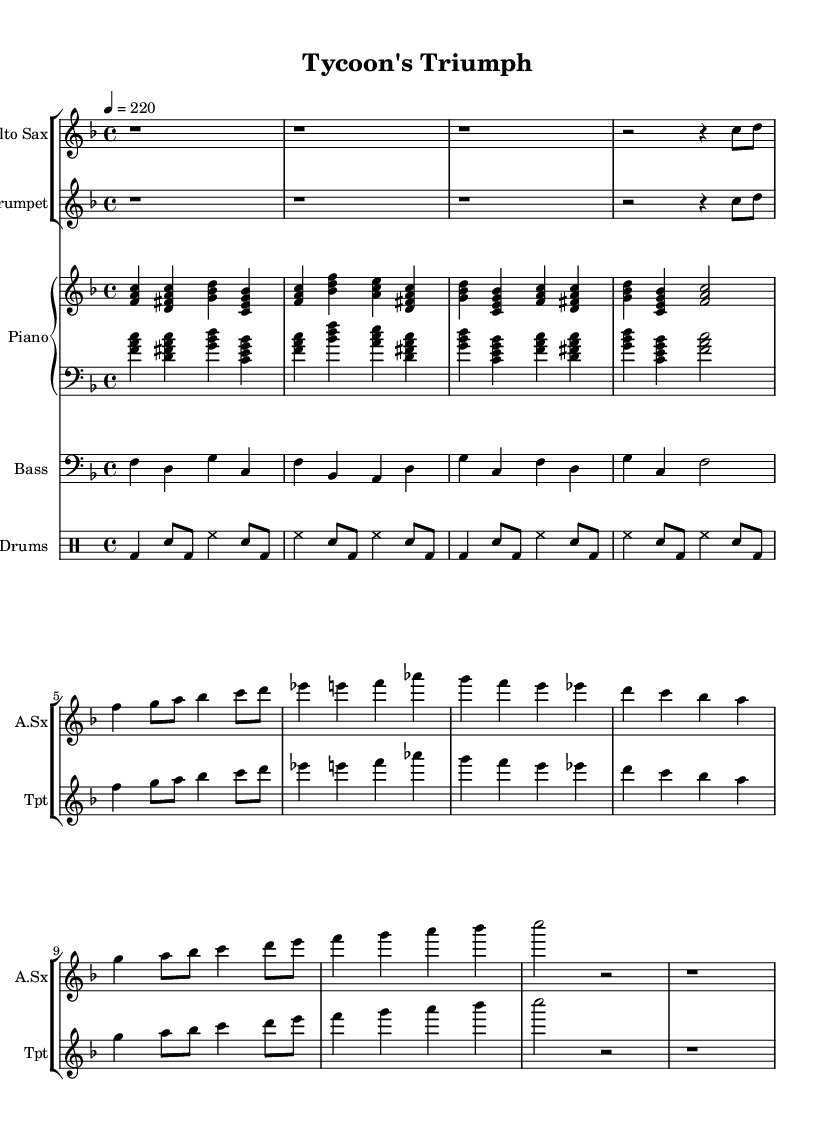What is the key signature of this music? The key signature is F major, which has one flat (B flat) indicated at the beginning of the staff.
Answer: F major What is the time signature of "Tycoon's Triumph"? The time signature is 4/4, meaning there are four beats per measure and the quarter note gets one beat. This is shown at the beginning of the sheet music.
Answer: 4/4 What is the tempo marking for this piece? The tempo marking states 4 = 220, indicating a fast pace of 220 beats per minute. This is significant for bebop, which is characterized by its high energy and speed.
Answer: 220 How many measures are in the first section of the saxophone part? The saxophone part has six measures in the first section, as indicated by the group of notes starting from the beginning up to the first double bar line.
Answer: 6 Which instruments are featured in this score? The score features the alto saxophone, trumpet, piano, bass, and drums, as indicated by their respective labels at the beginning of each staff.
Answer: Alto saxophone, trumpet, piano, bass, drums What musical form is commonly found in bebop pieces like this? Bebop pieces often utilize a 32-bar AABA form, which means they typically consist of two contrasting sections (A) followed by a bridge (B) and a return to the opening theme (A). This structure supports improvisation and development.
Answer: AABA 